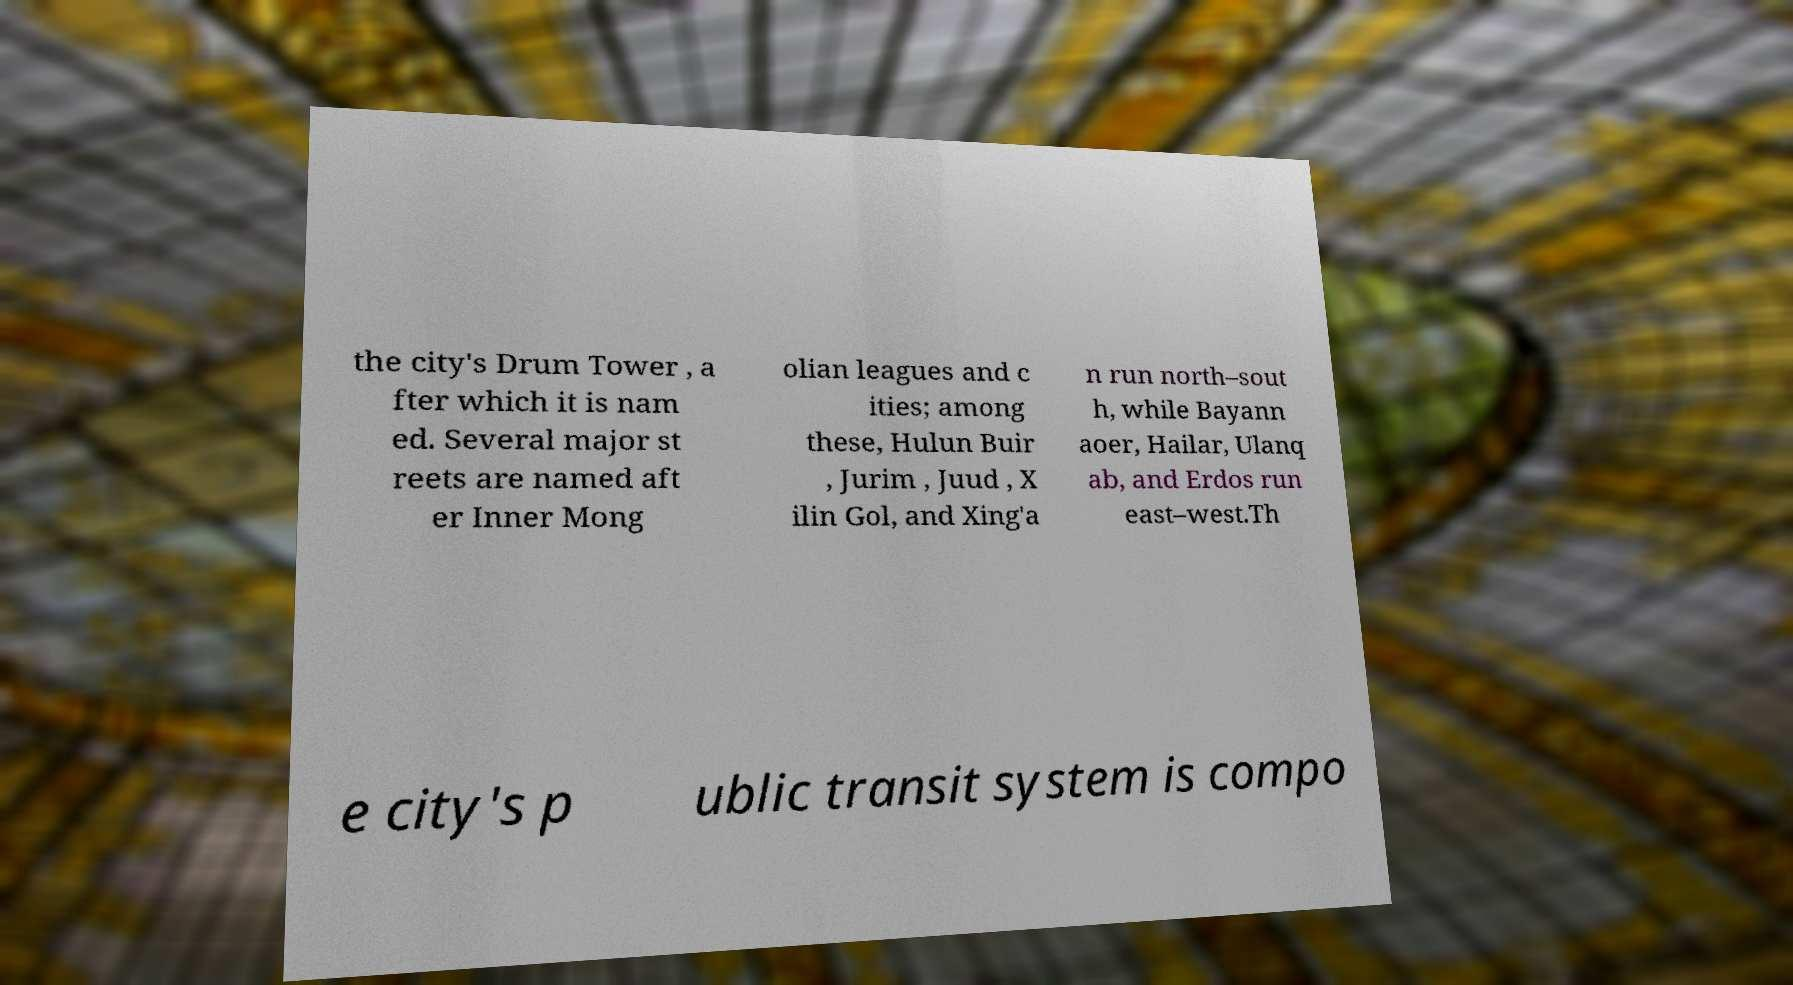Can you accurately transcribe the text from the provided image for me? the city's Drum Tower , a fter which it is nam ed. Several major st reets are named aft er Inner Mong olian leagues and c ities; among these, Hulun Buir , Jurim , Juud , X ilin Gol, and Xing'a n run north–sout h, while Bayann aoer, Hailar, Ulanq ab, and Erdos run east–west.Th e city's p ublic transit system is compo 